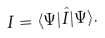Convert formula to latex. <formula><loc_0><loc_0><loc_500><loc_500>I = \langle \Psi | \hat { I } | \Psi \rangle .</formula> 